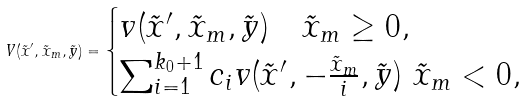<formula> <loc_0><loc_0><loc_500><loc_500>V ( \tilde { x } ^ { \prime } , \tilde { x } _ { m } , \tilde { y } ) = \begin{cases} v ( \tilde { x } ^ { \prime } , \tilde { x } _ { m } , \tilde { y } ) \quad \tilde { x } _ { m } \geq 0 , \\ \sum ^ { k _ { 0 } + 1 } _ { i = 1 } c _ { i } v ( \tilde { x } ^ { \prime } , - \frac { \tilde { x } _ { m } } { i } , \tilde { y } ) \ \tilde { x } _ { m } < 0 , \end{cases}</formula> 